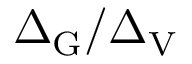<formula> <loc_0><loc_0><loc_500><loc_500>\Delta _ { G } / \Delta _ { V }</formula> 